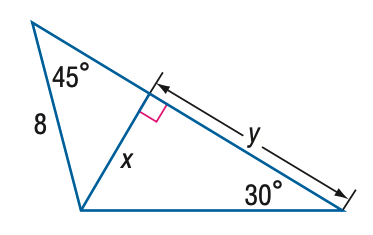Answer the mathemtical geometry problem and directly provide the correct option letter.
Question: Find y.
Choices: A: 4 \sqrt { 2 } B: 4 \sqrt { 3 } C: 4 \sqrt { 6 } D: 8 \sqrt { 6 } C 